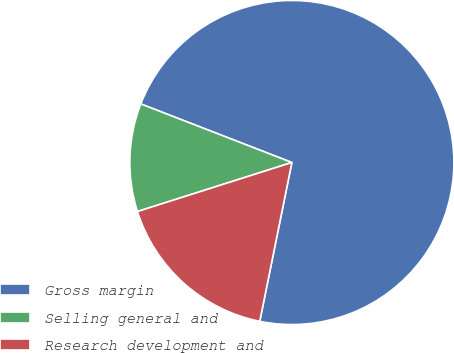Convert chart to OTSL. <chart><loc_0><loc_0><loc_500><loc_500><pie_chart><fcel>Gross margin<fcel>Selling general and<fcel>Research development and<nl><fcel>72.29%<fcel>10.78%<fcel>16.93%<nl></chart> 